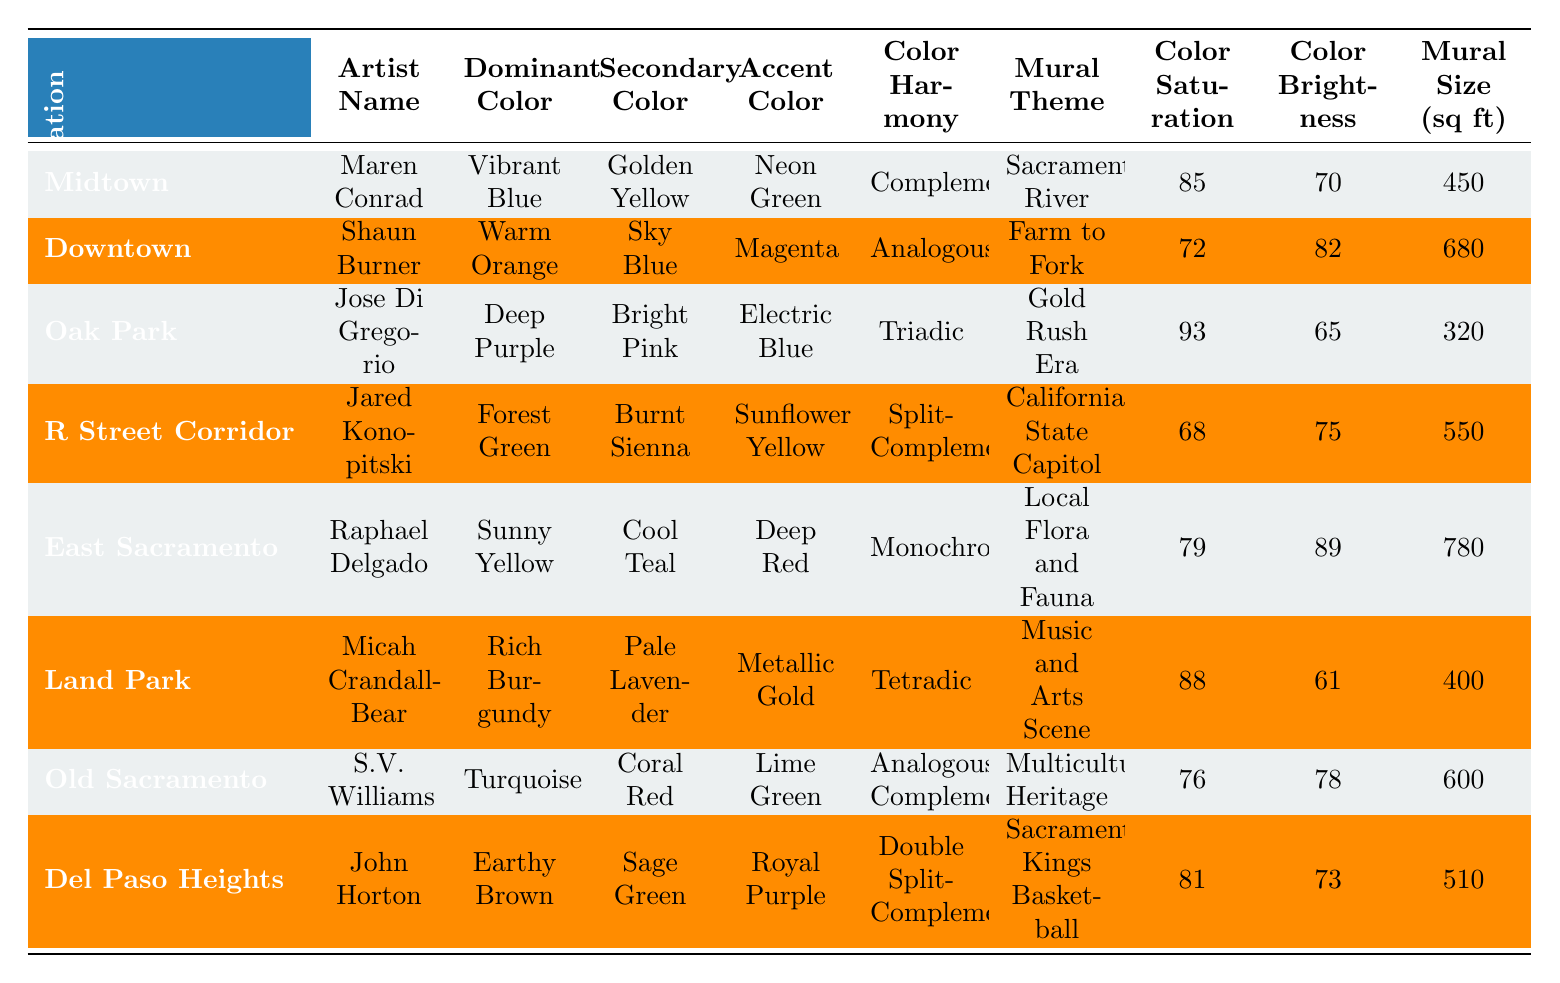What is the dominant color used in the mural located in Old Sacramento? The table shows the mural location "Old Sacramento" and lists the dominant color as "Turquoise."
Answer: Turquoise Which artist created the mural in Midtown? Looking at the table, under the "Mural Location" column, "Midtown" corresponds to the artist "Maren Conrad."
Answer: Maren Conrad What is the secondary color for the mural with a "Gold Rush Era" theme? The table indicates that the mural theme "Gold Rush Era" corresponds to the secondary color "Bright Pink" for the artist Jose Di Gregorio in Oak Park.
Answer: Bright Pink Which mural has the highest color saturation and what is that value? By examining the "Color Saturation" column, "Deep Purple," which is in "Oak Park," has the highest value of 93.
Answer: 93 Is "Electric Blue" listed as an accent color for any mural? The table shows that "Electric Blue" is listed as the accent color for the mural created by Jose Di Gregorio in Oak Park.
Answer: Yes What color harmony is used in the mural located in East Sacramento? Referring to the table, the mural in "East Sacramento" has a color harmony designation of "Monochromatic."
Answer: Monochromatic What is the average size of the murals listed in the table? The mural sizes in the table are: 450, 680, 320, 550, 780, 400, 600, 510. Summing these gives 3,890. Dividing by 8 (the number of murals) provides an average size of 486.25 sq ft.
Answer: 486.25 Which mural has the lowest color brightness, and what is that value? Observing the "Color Brightness" column, "Rich Burgundy" in Land Park has the lowest value at 61.
Answer: 61 Are there any murals with a dominant color of "Sunny Yellow"? The data shows that "Sunny Yellow" is indeed present as the dominant color for the mural created by Raphael Delgado in East Sacramento.
Answer: Yes What combination of colors is used for the accent in the mural with the "California State Capitol" theme? The table lists the mural with the "California State Capitol" theme as having an accent color of "Sunflower Yellow."
Answer: Sunflower Yellow 